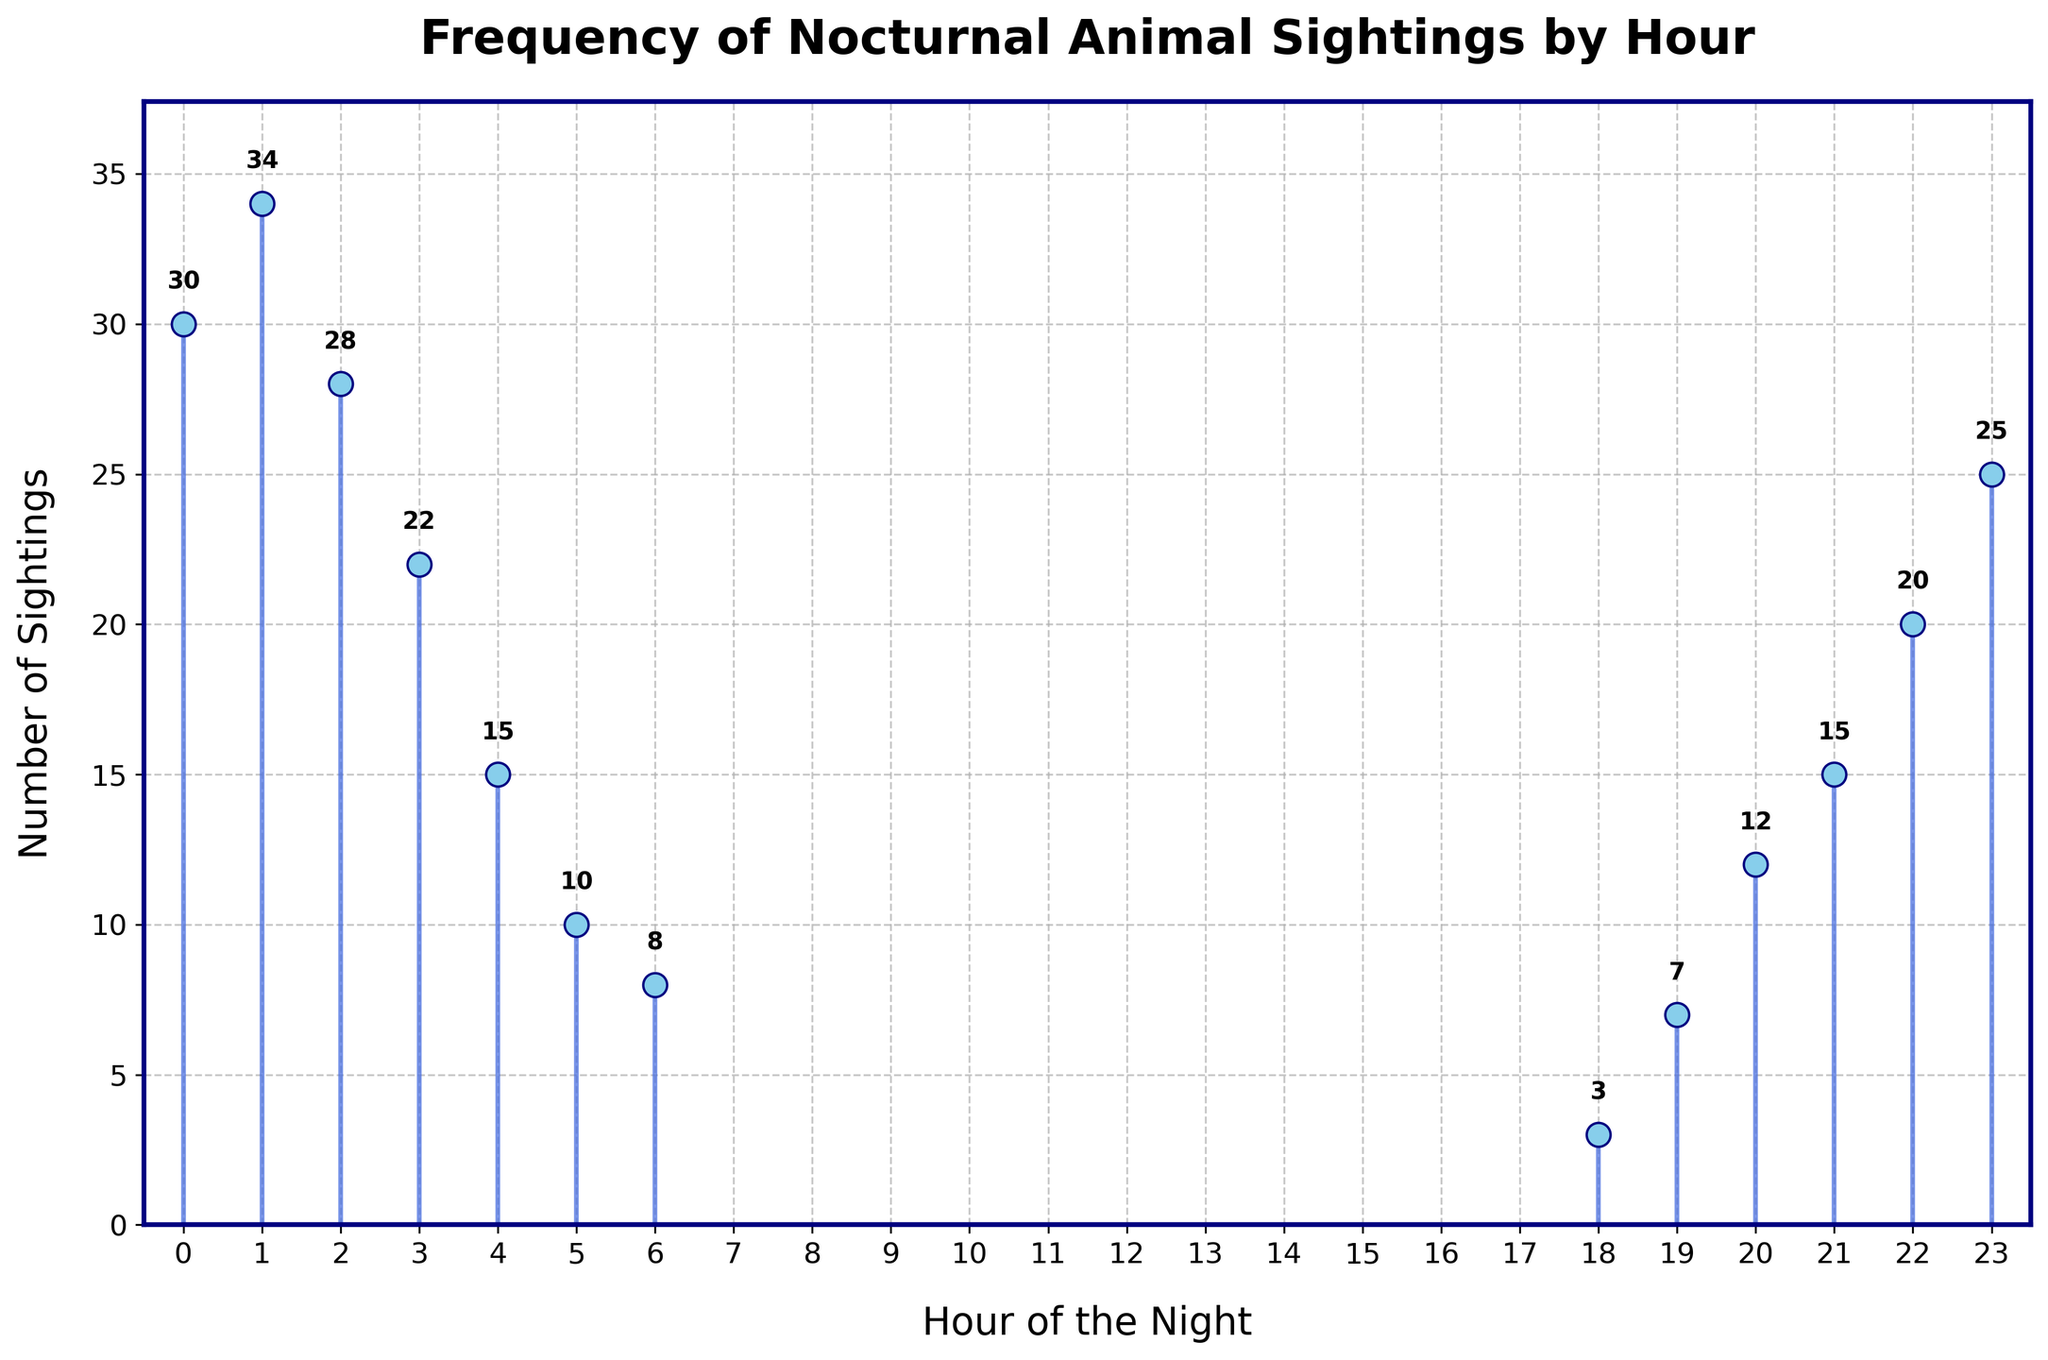What is the title of the stem plot? The title is placed at the top of the plot and usually summarizes the main topic or data being displayed. The title here reads "Frequency of Nocturnal Animal Sightings by Hour."
Answer: Frequency of Nocturnal Animal Sightings by Hour What is the highest number of sightings recorded in any hour? By looking at the vertical axis (y-axis) and finding the highest point reached by the stems, we can see the highest number of sightings is at hour 1, where the sighting count reaches 34.
Answer: 34 During which hour is the lowest number of sightings recorded? By observing the y-values of each stem, the shortest stem corresponds to hour 18, which has a count of 3 sightings.
Answer: 18 How many sightings were recorded in total from hours 22 to 0? To find this, add the number of sightings for each hour: 20 (22) + 25 (23) + 30 (0). This results in a total of 75 sightings.
Answer: 75 At what time is there a significant drop in sightings, and what is the difference in sightings between the two hours concerned? The most significant drop appears between hours 1 and 2. The number of sightings drops from 34 (hour 1) to 28 (hour 2). The difference is 34 - 28 = 6.
Answer: 1, 6 Which hour has the second highest number of sightings, and how many were there? By observing the stem plot, the highest is hour 1 with 34 sightings. The second highest is hour 0 with 30 sightings.
Answer: 0, 30 Is the number of sightings increasing or decreasing from hour 19 to hour 23? By tracing the y-values from hour 19 to hour 23, we see an increase from 7 (19) to 25 (23).
Answer: Increasing What is the average number of sightings between hours 21 and 3? Sum the sightings from hours 21, 22, 23, 0, 1, 2, and 3, which gives us 15 + 20 + 25 + 30 + 34 + 28 + 22 = 174. Calculate the average by dividing this sum by the number of hours (7), which gives us 174 / 7 = 24.86.
Answer: 24.86 Which hour shows a reverse trend compared to the surrounding hours, and what is the trend? From hour 2 to 4, the sightings decrease gradually from 28 to 22 to 15, then slightly increase to 10 at hour 5. The reverse trend occurs at hour 5.
Answer: 5, increase 